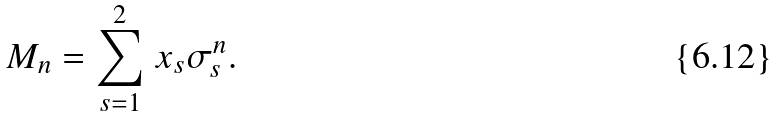<formula> <loc_0><loc_0><loc_500><loc_500>M _ { n } = \sum _ { s = 1 } ^ { 2 } \, x _ { s } \sigma _ { s } ^ { n } .</formula> 